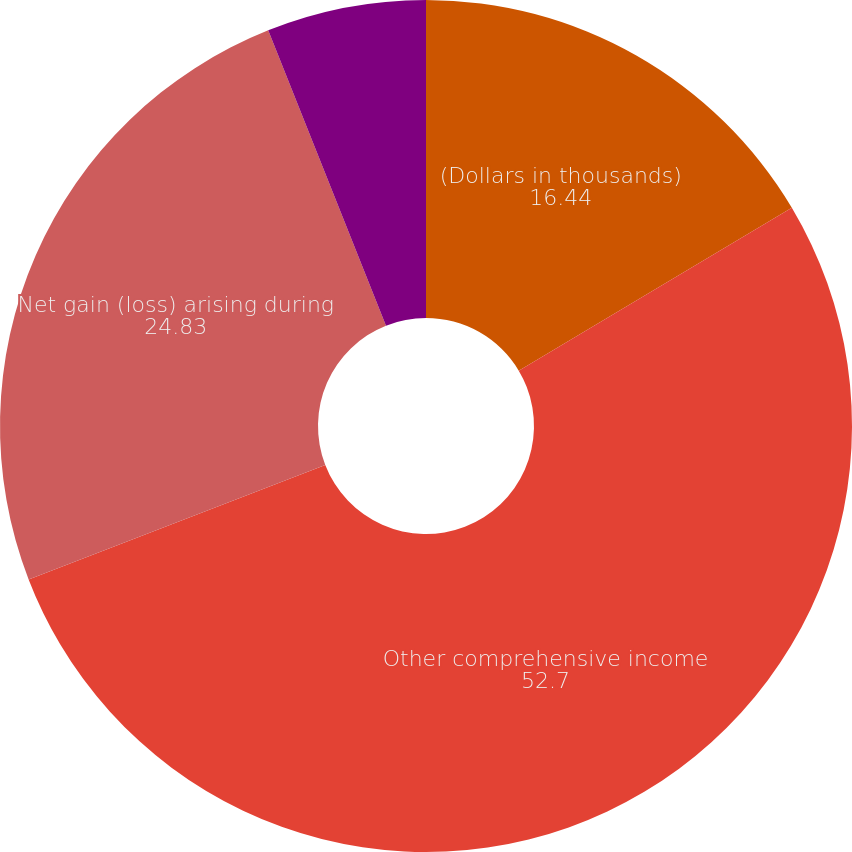<chart> <loc_0><loc_0><loc_500><loc_500><pie_chart><fcel>(Dollars in thousands)<fcel>Other comprehensive income<fcel>Net gain (loss) arising during<fcel>Actuarial loss (gain)<nl><fcel>16.44%<fcel>52.7%<fcel>24.83%<fcel>6.04%<nl></chart> 